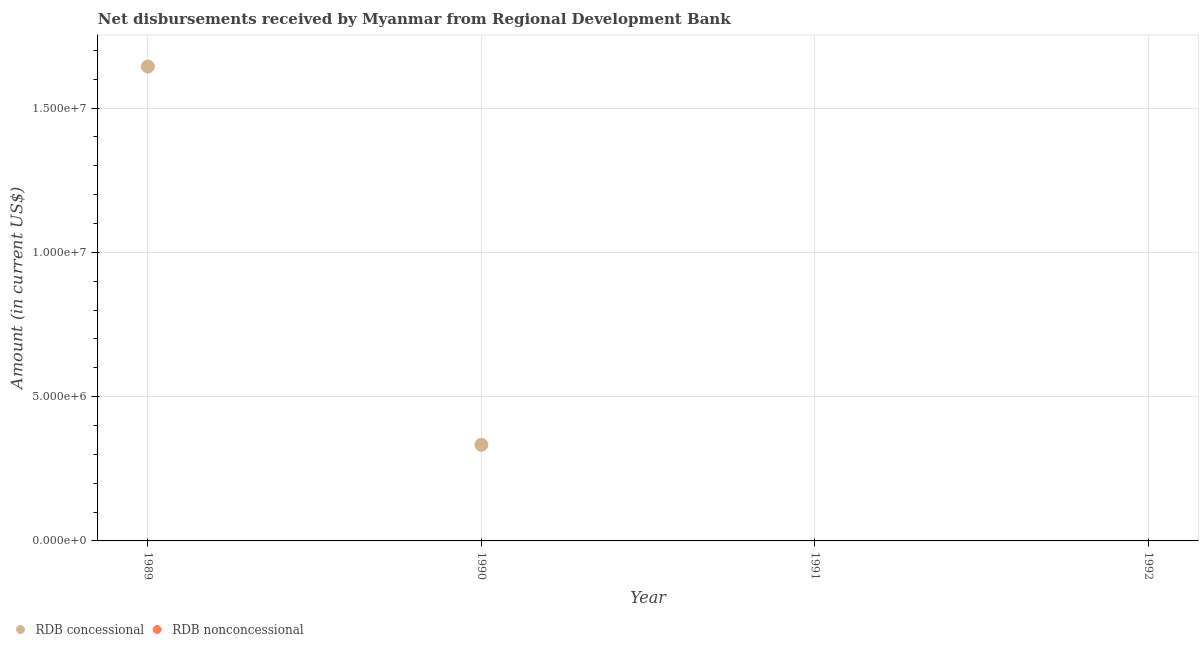How many different coloured dotlines are there?
Offer a very short reply. 1. What is the net concessional disbursements from rdb in 1990?
Give a very brief answer. 3.33e+06. Across all years, what is the maximum net concessional disbursements from rdb?
Provide a short and direct response. 1.64e+07. Across all years, what is the minimum net concessional disbursements from rdb?
Offer a very short reply. 0. In which year was the net concessional disbursements from rdb maximum?
Give a very brief answer. 1989. What is the total net non concessional disbursements from rdb in the graph?
Ensure brevity in your answer.  0. What is the difference between the net concessional disbursements from rdb in 1989 and that in 1990?
Offer a terse response. 1.31e+07. What is the difference between the net concessional disbursements from rdb in 1991 and the net non concessional disbursements from rdb in 1992?
Give a very brief answer. 0. What is the average net non concessional disbursements from rdb per year?
Provide a succinct answer. 0. In how many years, is the net non concessional disbursements from rdb greater than 14000000 US$?
Provide a succinct answer. 0. What is the difference between the highest and the lowest net concessional disbursements from rdb?
Ensure brevity in your answer.  1.64e+07. In how many years, is the net non concessional disbursements from rdb greater than the average net non concessional disbursements from rdb taken over all years?
Your response must be concise. 0. Is the sum of the net concessional disbursements from rdb in 1989 and 1990 greater than the maximum net non concessional disbursements from rdb across all years?
Provide a succinct answer. Yes. Does the net concessional disbursements from rdb monotonically increase over the years?
Your answer should be compact. No. Is the net non concessional disbursements from rdb strictly greater than the net concessional disbursements from rdb over the years?
Your answer should be very brief. No. Is the net non concessional disbursements from rdb strictly less than the net concessional disbursements from rdb over the years?
Ensure brevity in your answer.  No. How many years are there in the graph?
Provide a succinct answer. 4. Are the values on the major ticks of Y-axis written in scientific E-notation?
Provide a short and direct response. Yes. Does the graph contain any zero values?
Give a very brief answer. Yes. Does the graph contain grids?
Provide a succinct answer. Yes. Where does the legend appear in the graph?
Offer a terse response. Bottom left. How many legend labels are there?
Offer a very short reply. 2. How are the legend labels stacked?
Your answer should be very brief. Horizontal. What is the title of the graph?
Ensure brevity in your answer.  Net disbursements received by Myanmar from Regional Development Bank. Does "Mobile cellular" appear as one of the legend labels in the graph?
Your answer should be very brief. No. What is the label or title of the X-axis?
Keep it short and to the point. Year. What is the Amount (in current US$) of RDB concessional in 1989?
Offer a terse response. 1.64e+07. What is the Amount (in current US$) of RDB concessional in 1990?
Keep it short and to the point. 3.33e+06. What is the Amount (in current US$) of RDB concessional in 1992?
Give a very brief answer. 0. What is the Amount (in current US$) of RDB nonconcessional in 1992?
Provide a succinct answer. 0. Across all years, what is the maximum Amount (in current US$) in RDB concessional?
Your answer should be compact. 1.64e+07. What is the total Amount (in current US$) in RDB concessional in the graph?
Offer a terse response. 1.98e+07. What is the total Amount (in current US$) in RDB nonconcessional in the graph?
Keep it short and to the point. 0. What is the difference between the Amount (in current US$) in RDB concessional in 1989 and that in 1990?
Provide a short and direct response. 1.31e+07. What is the average Amount (in current US$) in RDB concessional per year?
Provide a short and direct response. 4.94e+06. What is the ratio of the Amount (in current US$) of RDB concessional in 1989 to that in 1990?
Provide a succinct answer. 4.94. What is the difference between the highest and the lowest Amount (in current US$) of RDB concessional?
Offer a terse response. 1.64e+07. 